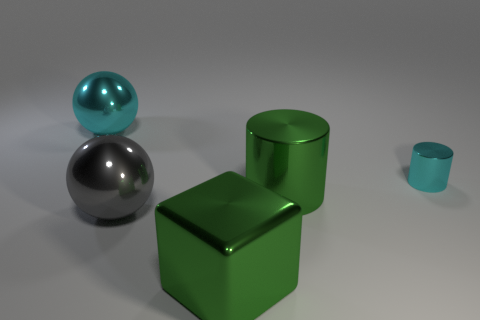Subtract all cyan cylinders. How many cylinders are left? 1 Subtract 1 cylinders. How many cylinders are left? 1 Subtract all cylinders. How many objects are left? 3 Subtract all yellow cylinders. How many gray spheres are left? 1 Add 5 tiny purple metal spheres. How many objects exist? 10 Subtract all blue spheres. Subtract all yellow cylinders. How many spheres are left? 2 Subtract all blue metallic cylinders. Subtract all green metallic cylinders. How many objects are left? 4 Add 2 small cyan metal cylinders. How many small cyan metal cylinders are left? 3 Add 2 large gray rubber cylinders. How many large gray rubber cylinders exist? 2 Subtract 0 red cylinders. How many objects are left? 5 